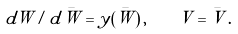<formula> <loc_0><loc_0><loc_500><loc_500>d W / d { \bar { W } } = y ( \bar { W } ) \, , \quad V = { \bar { V } } \, .</formula> 